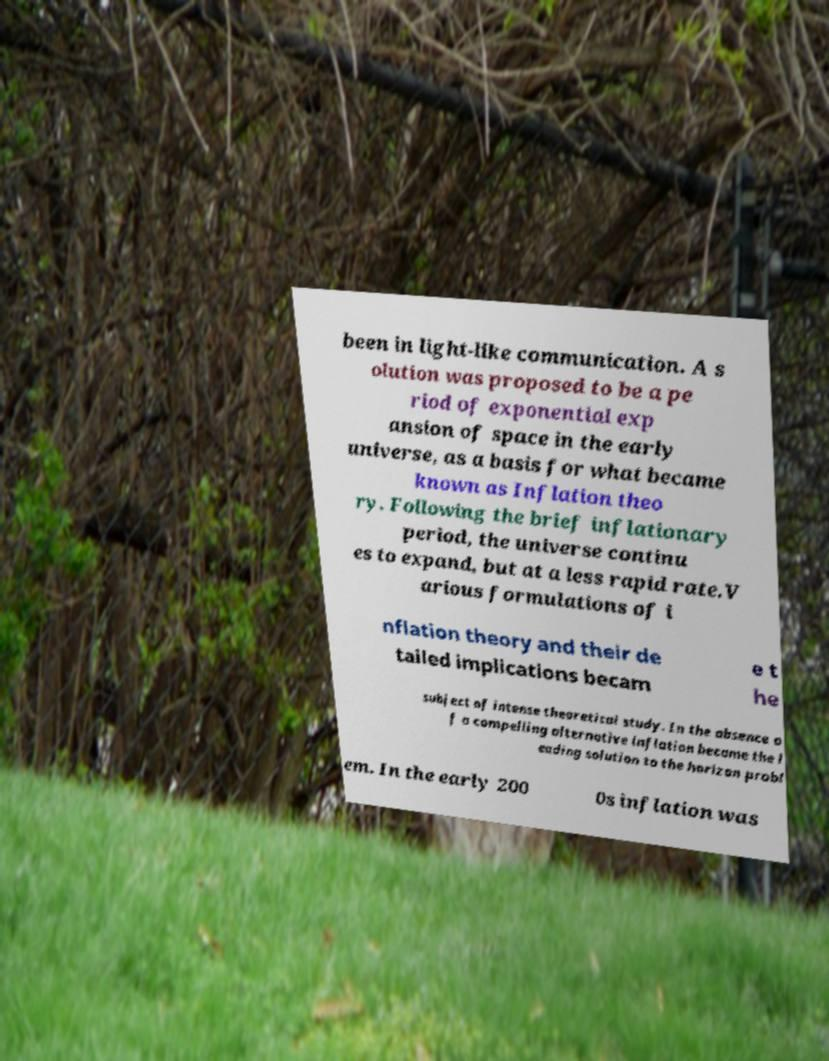Please identify and transcribe the text found in this image. been in light-like communication. A s olution was proposed to be a pe riod of exponential exp ansion of space in the early universe, as a basis for what became known as Inflation theo ry. Following the brief inflationary period, the universe continu es to expand, but at a less rapid rate.V arious formulations of i nflation theory and their de tailed implications becam e t he subject of intense theoretical study. In the absence o f a compelling alternative inflation became the l eading solution to the horizon probl em. In the early 200 0s inflation was 